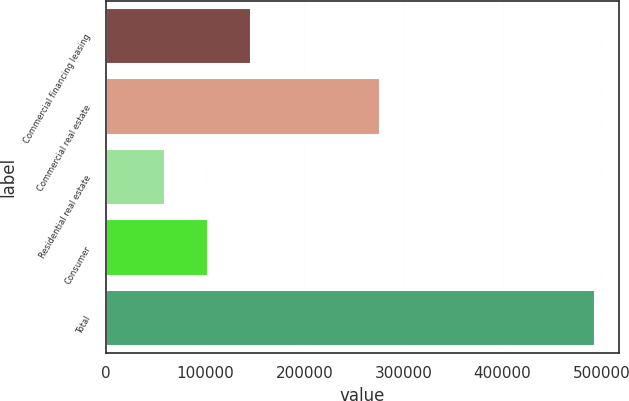<chart> <loc_0><loc_0><loc_500><loc_500><bar_chart><fcel>Commercial financing leasing<fcel>Commercial real estate<fcel>Residential real estate<fcel>Consumer<fcel>Total<nl><fcel>146199<fcel>276681<fcel>59552<fcel>102876<fcel>492788<nl></chart> 